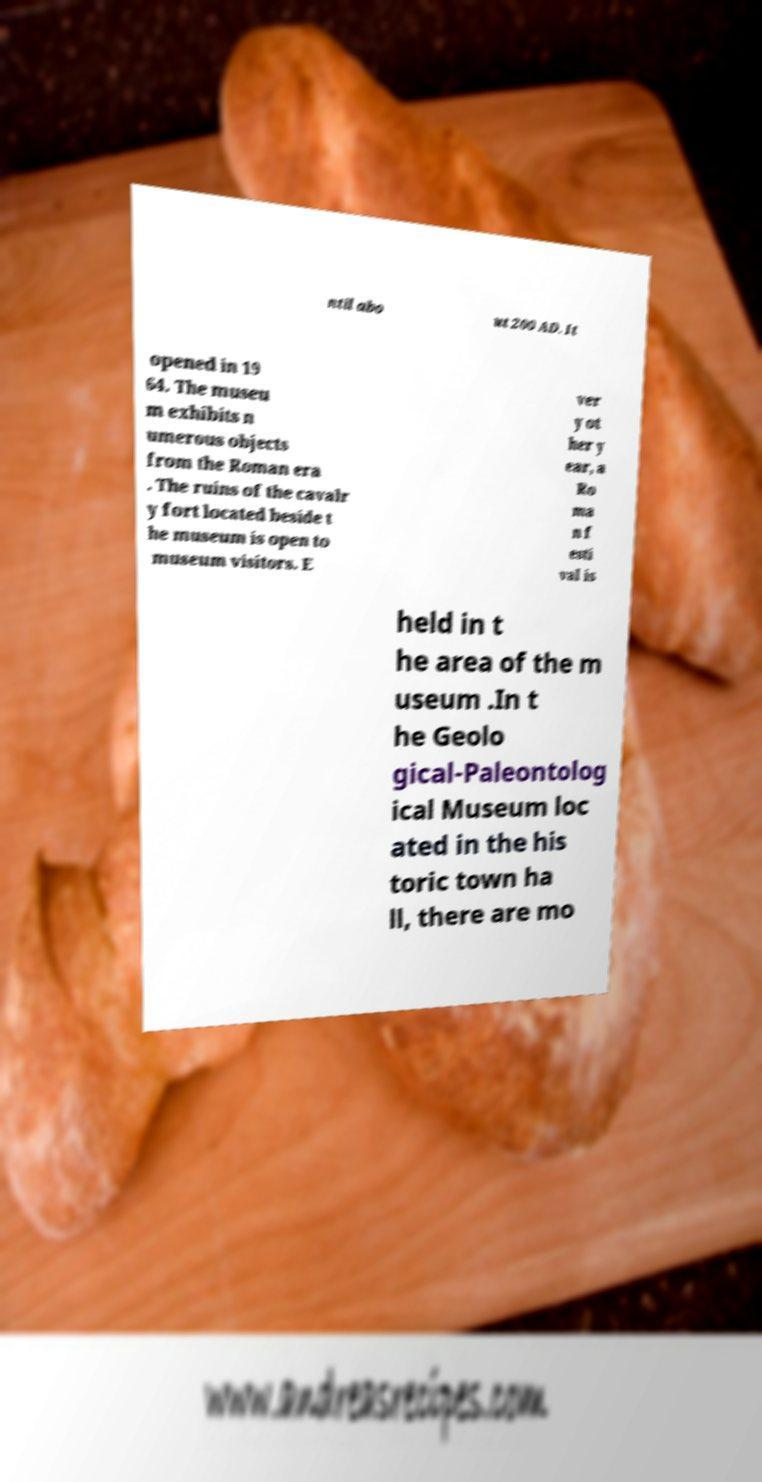Please identify and transcribe the text found in this image. ntil abo ut 200 AD. It opened in 19 64. The museu m exhibits n umerous objects from the Roman era . The ruins of the cavalr y fort located beside t he museum is open to museum visitors. E ver y ot her y ear, a Ro ma n f esti val is held in t he area of the m useum .In t he Geolo gical-Paleontolog ical Museum loc ated in the his toric town ha ll, there are mo 